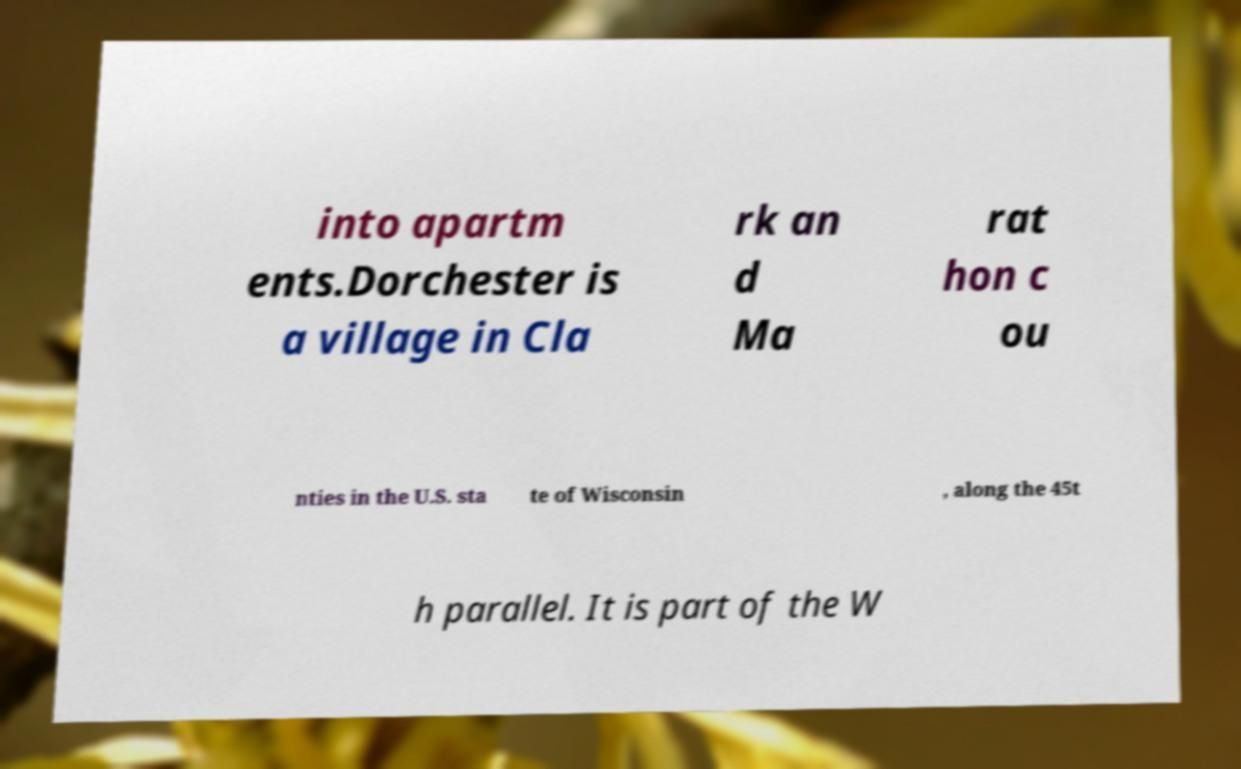Can you read and provide the text displayed in the image?This photo seems to have some interesting text. Can you extract and type it out for me? into apartm ents.Dorchester is a village in Cla rk an d Ma rat hon c ou nties in the U.S. sta te of Wisconsin , along the 45t h parallel. It is part of the W 